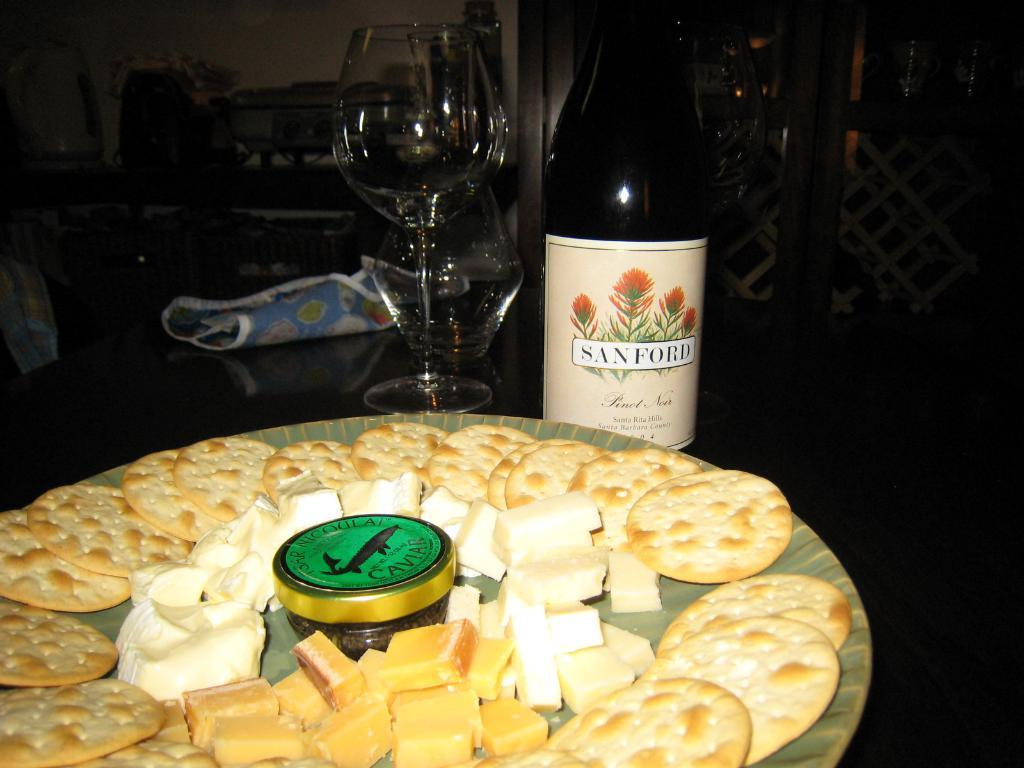<image>
Offer a succinct explanation of the picture presented. a plate of cheese and crackers and a bottle of sanford by it 